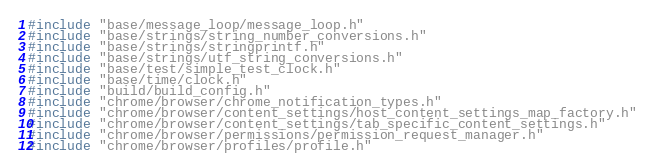<code> <loc_0><loc_0><loc_500><loc_500><_C++_>#include "base/message_loop/message_loop.h"
#include "base/strings/string_number_conversions.h"
#include "base/strings/stringprintf.h"
#include "base/strings/utf_string_conversions.h"
#include "base/test/simple_test_clock.h"
#include "base/time/clock.h"
#include "build/build_config.h"
#include "chrome/browser/chrome_notification_types.h"
#include "chrome/browser/content_settings/host_content_settings_map_factory.h"
#include "chrome/browser/content_settings/tab_specific_content_settings.h"
#include "chrome/browser/permissions/permission_request_manager.h"
#include "chrome/browser/profiles/profile.h"</code> 